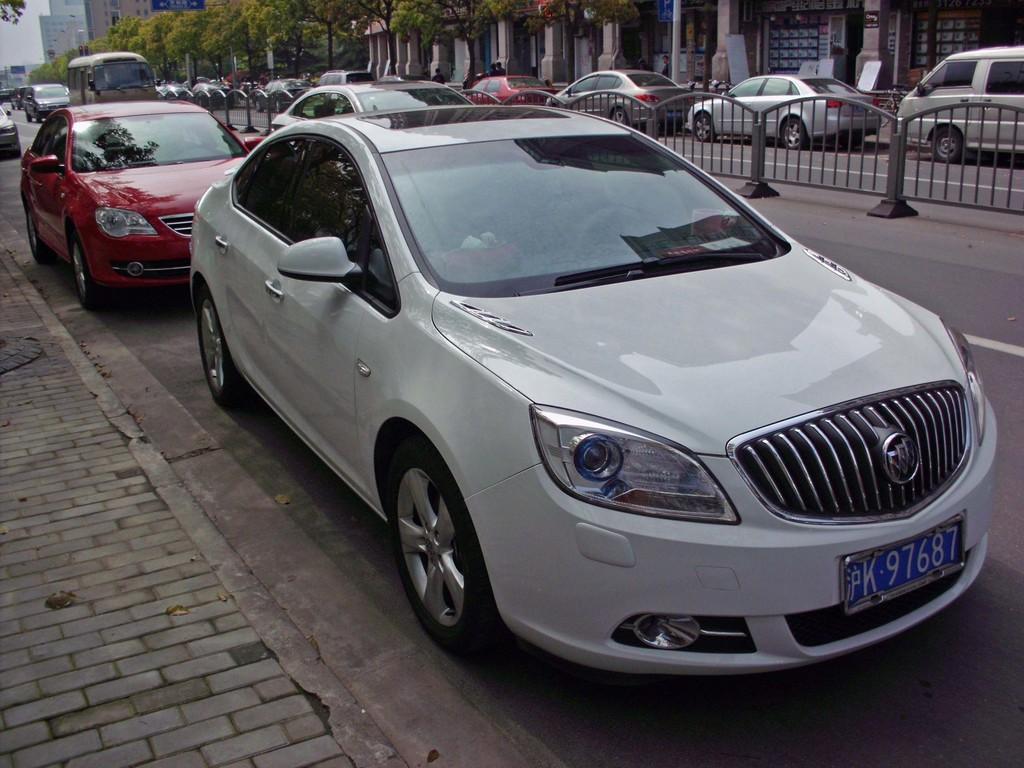Please provide a concise description of this image. In this picture we can see vehicles on the road and fence. In the background of the image we can see buildings, trees and sky. 